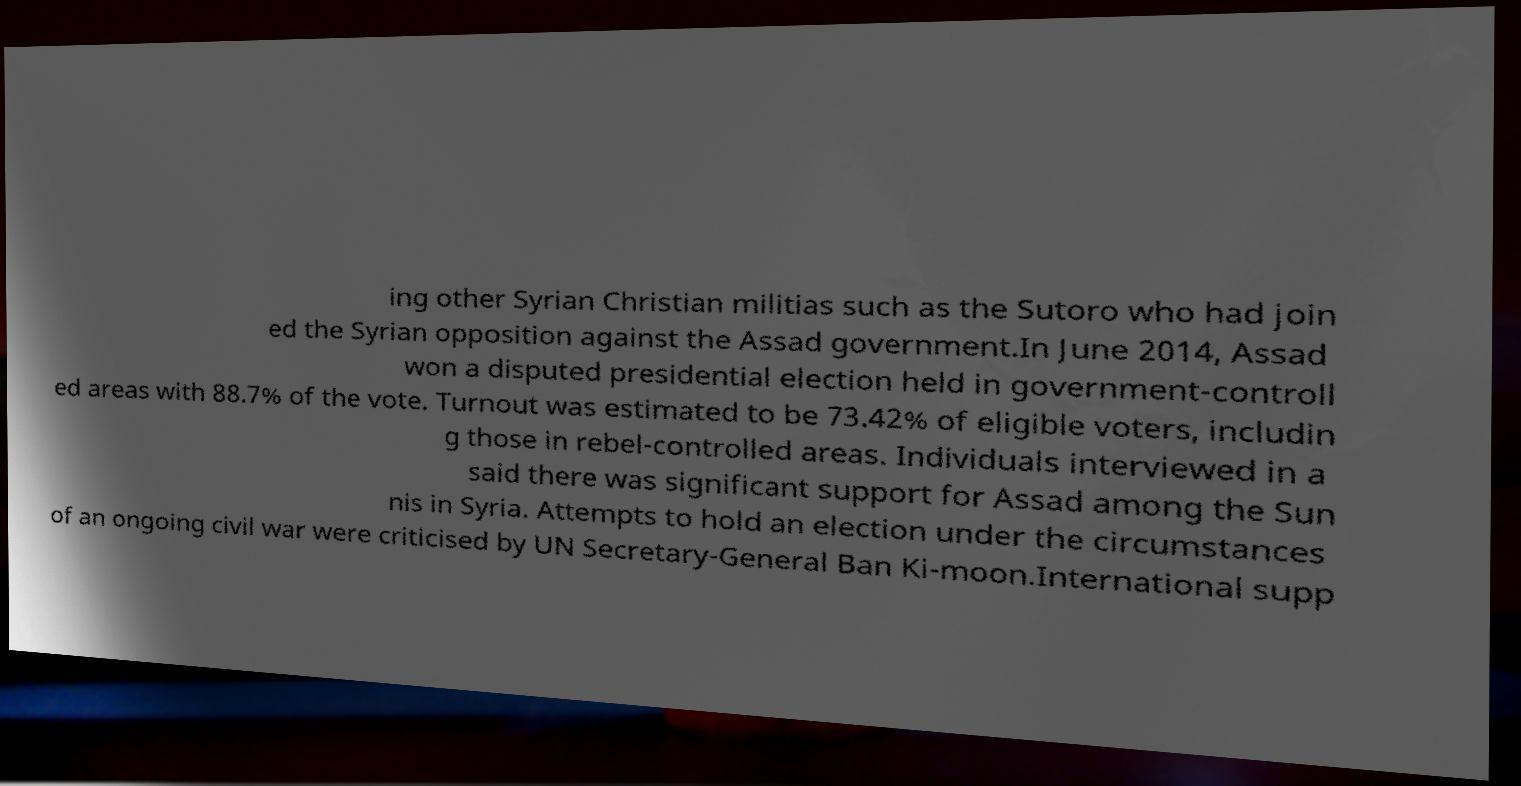For documentation purposes, I need the text within this image transcribed. Could you provide that? ing other Syrian Christian militias such as the Sutoro who had join ed the Syrian opposition against the Assad government.In June 2014, Assad won a disputed presidential election held in government-controll ed areas with 88.7% of the vote. Turnout was estimated to be 73.42% of eligible voters, includin g those in rebel-controlled areas. Individuals interviewed in a said there was significant support for Assad among the Sun nis in Syria. Attempts to hold an election under the circumstances of an ongoing civil war were criticised by UN Secretary-General Ban Ki-moon.International supp 